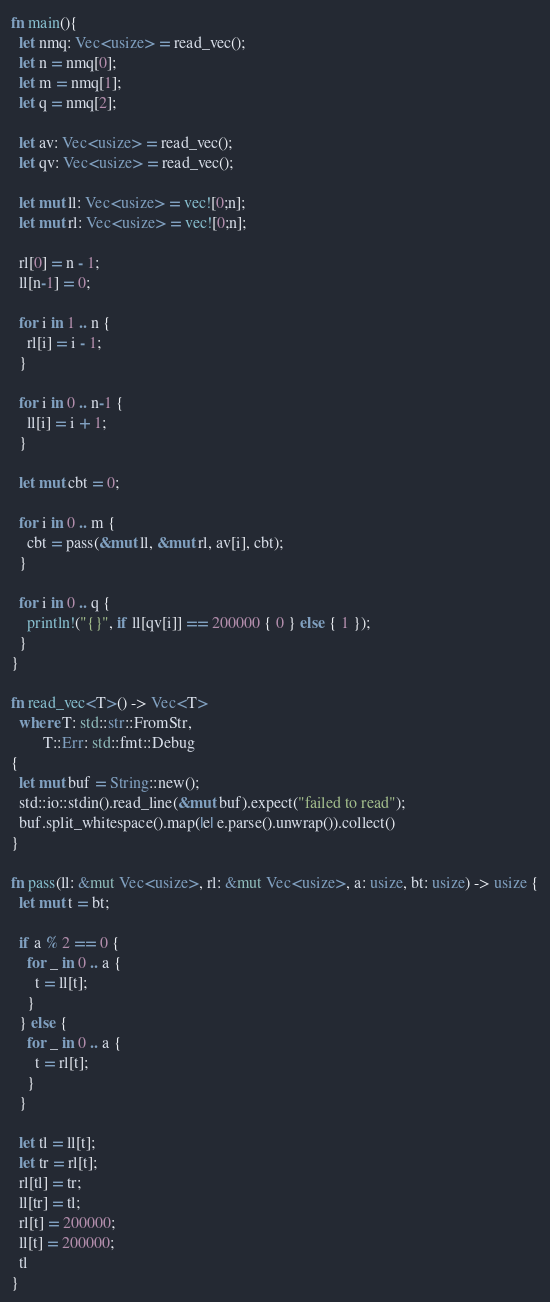Convert code to text. <code><loc_0><loc_0><loc_500><loc_500><_Rust_>fn main(){
  let nmq: Vec<usize> = read_vec();
  let n = nmq[0];
  let m = nmq[1];
  let q = nmq[2];

  let av: Vec<usize> = read_vec();
  let qv: Vec<usize> = read_vec();

  let mut ll: Vec<usize> = vec![0;n];
  let mut rl: Vec<usize> = vec![0;n];

  rl[0] = n - 1;
  ll[n-1] = 0;

  for i in 1 .. n {
    rl[i] = i - 1;
  }

  for i in 0 .. n-1 {
    ll[i] = i + 1;
  }

  let mut cbt = 0;
  
  for i in 0 .. m {
    cbt = pass(&mut ll, &mut rl, av[i], cbt);
  }

  for i in 0 .. q {
    println!("{}", if ll[qv[i]] == 200000 { 0 } else { 1 });
  }
}

fn read_vec<T>() -> Vec<T>
  where T: std::str::FromStr,
        T::Err: std::fmt::Debug
{
  let mut buf = String::new();
  std::io::stdin().read_line(&mut buf).expect("failed to read");
  buf.split_whitespace().map(|e| e.parse().unwrap()).collect()
}

fn pass(ll: &mut Vec<usize>, rl: &mut Vec<usize>, a: usize, bt: usize) -> usize {
  let mut t = bt;
  
  if a % 2 == 0 {
    for _ in 0 .. a {
      t = ll[t];
    }
  } else {
    for _ in 0 .. a {
      t = rl[t];
    }
  }
  
  let tl = ll[t];
  let tr = rl[t];
  rl[tl] = tr;
  ll[tr] = tl;
  rl[t] = 200000;
  ll[t] = 200000;
  tl
}

</code> 